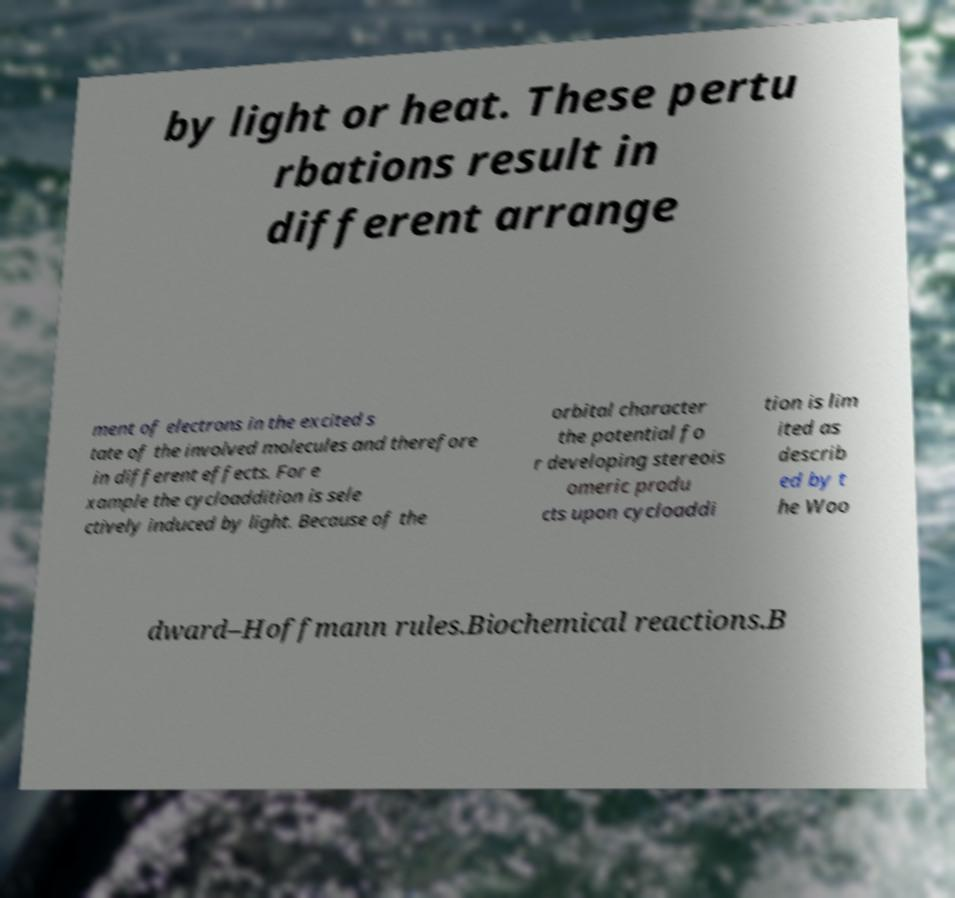Can you read and provide the text displayed in the image?This photo seems to have some interesting text. Can you extract and type it out for me? by light or heat. These pertu rbations result in different arrange ment of electrons in the excited s tate of the involved molecules and therefore in different effects. For e xample the cycloaddition is sele ctively induced by light. Because of the orbital character the potential fo r developing stereois omeric produ cts upon cycloaddi tion is lim ited as describ ed by t he Woo dward–Hoffmann rules.Biochemical reactions.B 